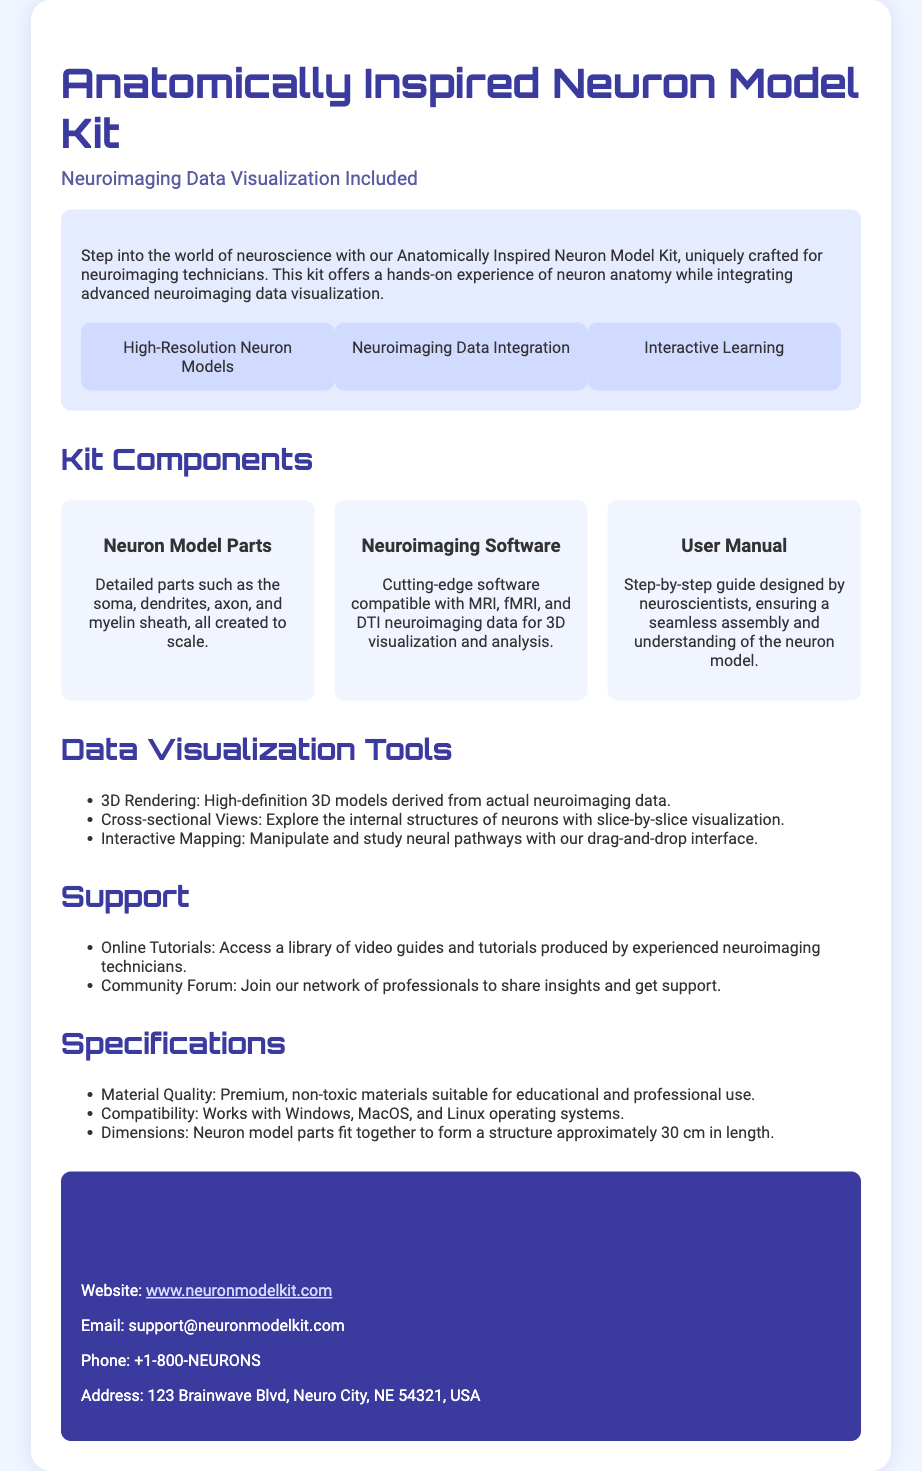What is included in the kit? The kit includes high-resolution neuron models, neuroimaging data integration, and interactive learning features.
Answer: high-resolution neuron models, neuroimaging data integration, interactive learning What is the length of the assembled neuron model? The assembled neuron model has dimensions that fit together to form a structure approximately 30 cm in length.
Answer: 30 cm What types of neuroimaging data does the included software support? The neuroimaging software is compatible with MRI, fMRI, and DTI neuroimaging data.
Answer: MRI, fMRI, DTI What kind of materials are used for the neuron model parts? The materials used in the neuron model parts are described as premium, non-toxic materials.
Answer: premium, non-toxic materials What online resources are offered for support? The support includes online tutorials and a community forum for professional networking.
Answer: online tutorials, community forum How is the neuron model designed for its assembly? The assembly is guided by a user manual designed by neuroscientists.
Answer: user manual What does the neuroimaging data visualization tool allow users to do? The data visualization tools allow users to perform 3D rendering, cross-sectional views, and interactive mapping of neural pathways.
Answer: 3D rendering, cross-sectional views, interactive mapping What is the website for more information? The contact information specifies that the website for more information is provided in the document.
Answer: www.neuronmodelkit.com 